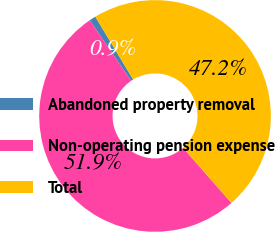Convert chart. <chart><loc_0><loc_0><loc_500><loc_500><pie_chart><fcel>Abandoned property removal<fcel>Non-operating pension expense<fcel>Total<nl><fcel>0.91%<fcel>51.94%<fcel>47.15%<nl></chart> 